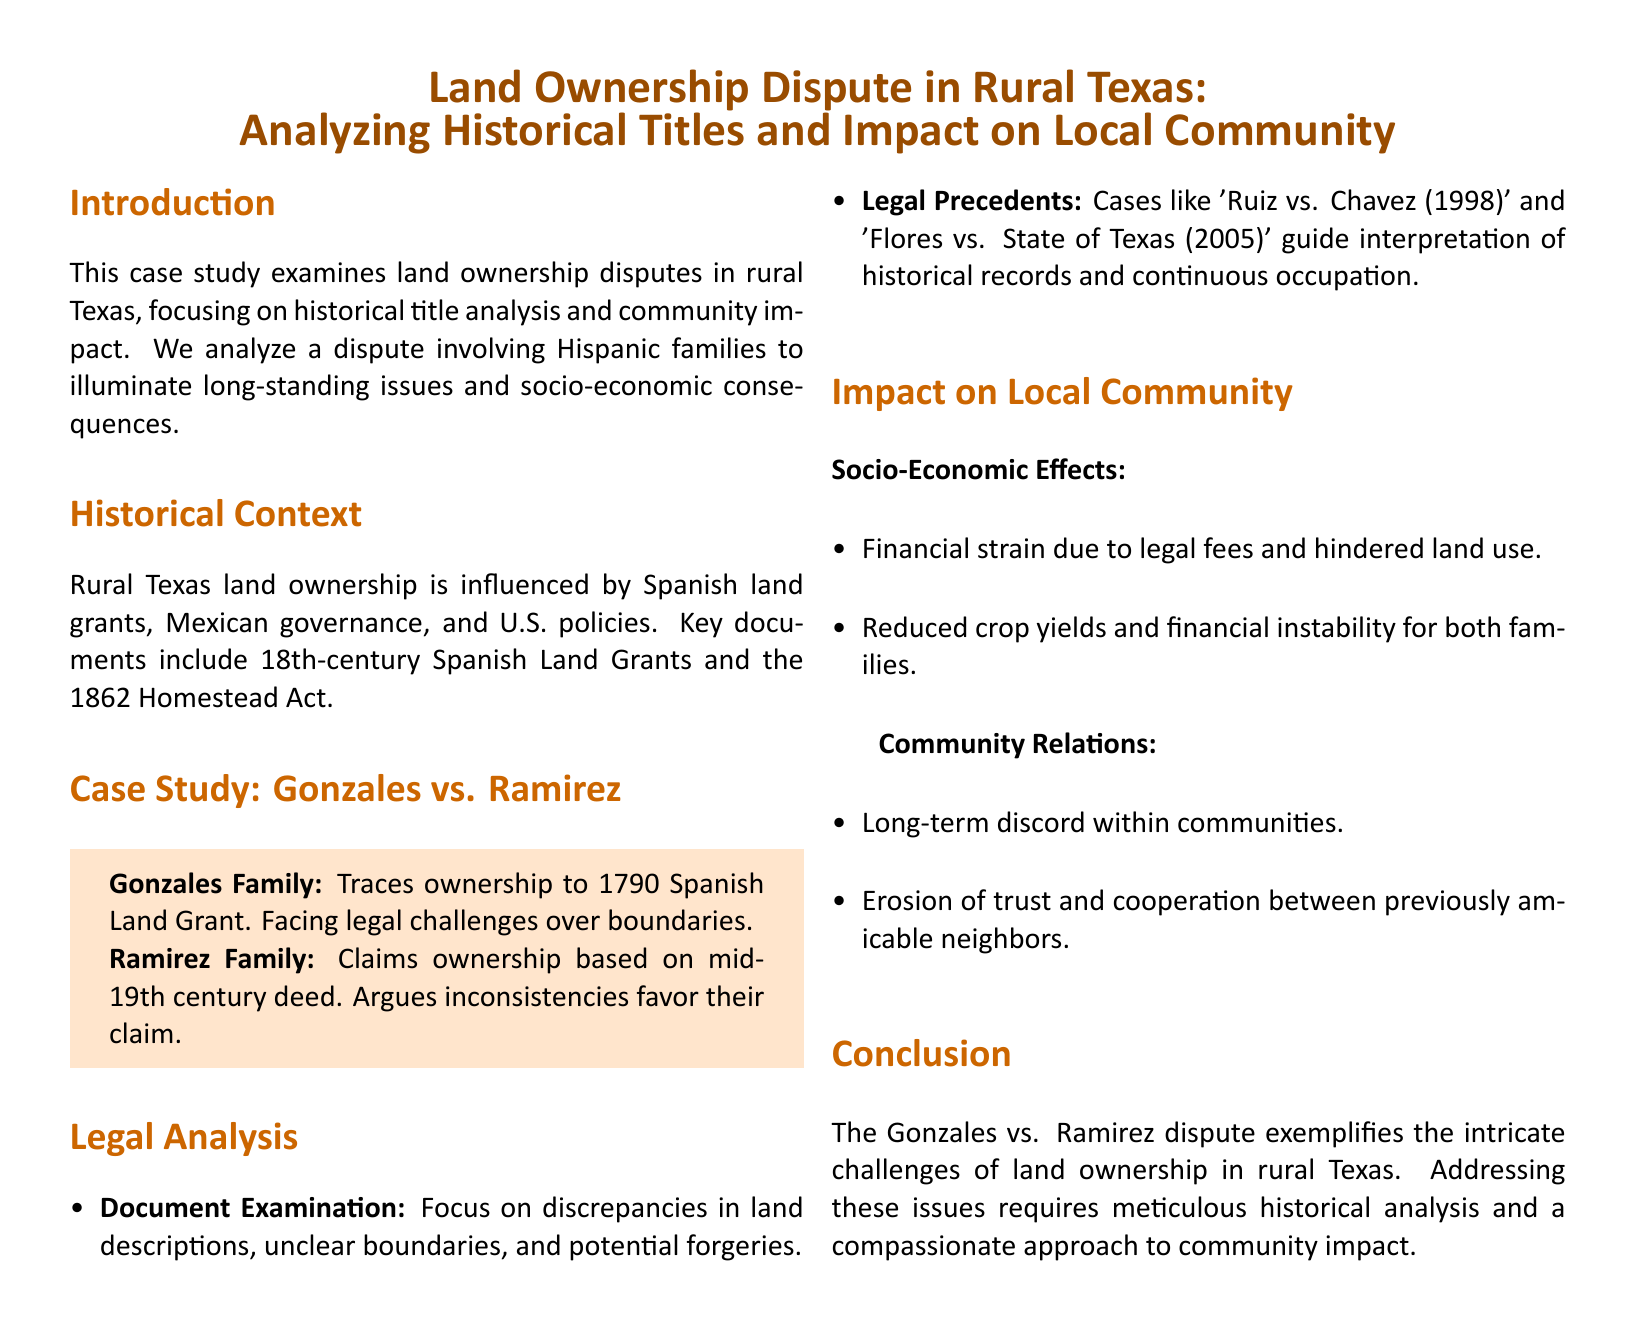what families are involved in the dispute? The document identifies the Gonzales Family and the Ramirez Family as the parties involved in the dispute.
Answer: Gonzales Family, Ramirez Family when was the Spanish Land Grant traced by the Gonzales Family? The Gonzales Family traces ownership to the year 1790 based on a Spanish Land Grant.
Answer: 1790 what act is mentioned as influential in land ownership policy? The 1862 Homestead Act is highlighted as a significant policy affecting land ownership in the document.
Answer: 1862 Homestead Act which legal case is mentioned as a precedent related to historical records? The case 'Ruiz vs. Chavez (1998)' is cited as a legal precedent that guides the interpretation of historical records.
Answer: Ruiz vs. Chavez (1998) what are one of the socio-economic effects on the families? The document states that financial strain due to legal fees is one of the socio-economic effects experienced by the families.
Answer: Financial strain how has the dispute affected community relations? The dispute has led to the erosion of trust and cooperation between the previously amicable neighbors.
Answer: Erosion of trust what year does the Ramirez Family's claim date back to? The Ramirez Family's claim is based on a deed from the mid-19th century.
Answer: Mid-19th century what method is mentioned to examine the legal case? The document mentions 'Document Examination' as a method for analyzing the legal case.
Answer: Document Examination what is the primary focus of the case study? The case study primarily focuses on historical title analysis and its impact on the local community regarding land ownership disputes.
Answer: Historical title analysis 